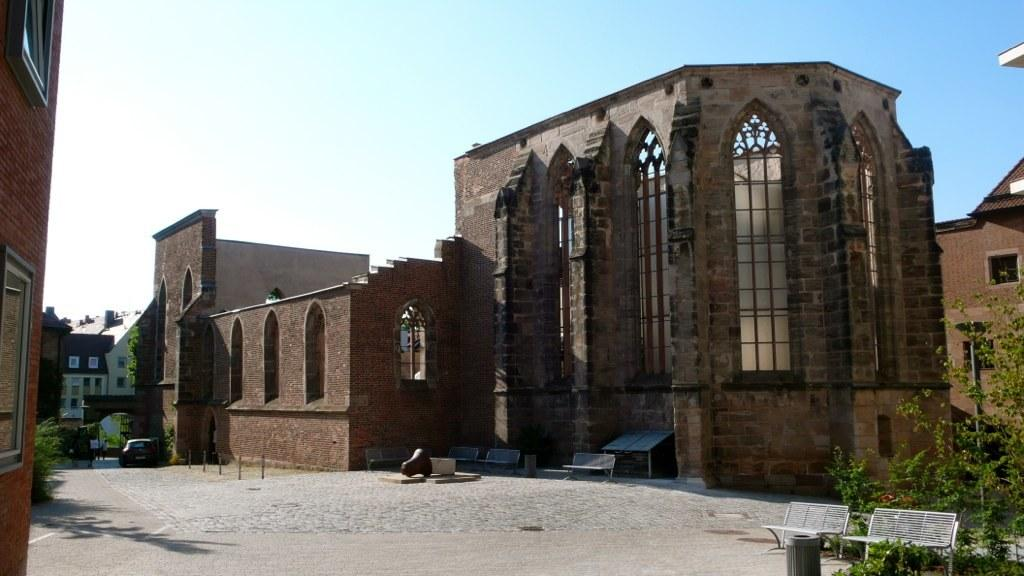What is a part of the natural environment visible in the image? The sky is visible in the image. What type of man-made structures can be seen in the image? There are buildings in the image. What architectural feature is present in the image? The image contains windows. What type of vegetation is present in the image? Trees are present in the image. What type of seating is available in the image? There are benches in the image. What type of transportation is visible in the image? There is at least one vehicle in the image. What other objects can be seen in the image? There are other objects in the image, but their specific nature is not mentioned in the provided facts. What type of impulse can be seen affecting the trees in the image? There is no indication of any impulse affecting the trees in the image; they appear to be stationary. What type of place is depicted in the image? The image does not depict a specific place; it contains a general scene with buildings, trees, and other objects. 